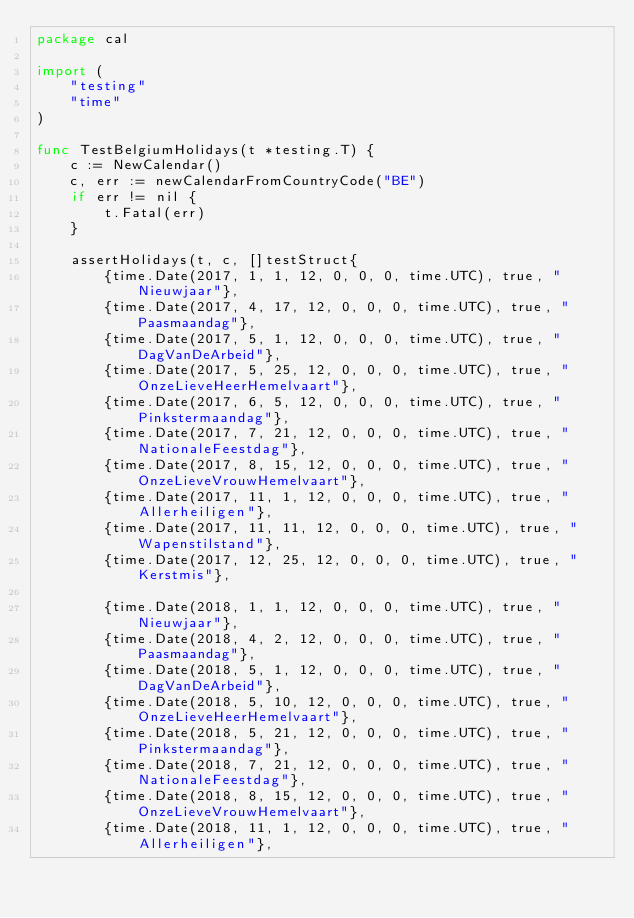Convert code to text. <code><loc_0><loc_0><loc_500><loc_500><_Go_>package cal

import (
	"testing"
	"time"
)

func TestBelgiumHolidays(t *testing.T) {
	c := NewCalendar()
	c, err := newCalendarFromCountryCode("BE")
	if err != nil {
		t.Fatal(err)
	}

	assertHolidays(t, c, []testStruct{
		{time.Date(2017, 1, 1, 12, 0, 0, 0, time.UTC), true, "Nieuwjaar"},
		{time.Date(2017, 4, 17, 12, 0, 0, 0, time.UTC), true, "Paasmaandag"},
		{time.Date(2017, 5, 1, 12, 0, 0, 0, time.UTC), true, "DagVanDeArbeid"},
		{time.Date(2017, 5, 25, 12, 0, 0, 0, time.UTC), true, "OnzeLieveHeerHemelvaart"},
		{time.Date(2017, 6, 5, 12, 0, 0, 0, time.UTC), true, "Pinkstermaandag"},
		{time.Date(2017, 7, 21, 12, 0, 0, 0, time.UTC), true, "NationaleFeestdag"},
		{time.Date(2017, 8, 15, 12, 0, 0, 0, time.UTC), true, "OnzeLieveVrouwHemelvaart"},
		{time.Date(2017, 11, 1, 12, 0, 0, 0, time.UTC), true, "Allerheiligen"},
		{time.Date(2017, 11, 11, 12, 0, 0, 0, time.UTC), true, "Wapenstilstand"},
		{time.Date(2017, 12, 25, 12, 0, 0, 0, time.UTC), true, "Kerstmis"},

		{time.Date(2018, 1, 1, 12, 0, 0, 0, time.UTC), true, "Nieuwjaar"},
		{time.Date(2018, 4, 2, 12, 0, 0, 0, time.UTC), true, "Paasmaandag"},
		{time.Date(2018, 5, 1, 12, 0, 0, 0, time.UTC), true, "DagVanDeArbeid"},
		{time.Date(2018, 5, 10, 12, 0, 0, 0, time.UTC), true, "OnzeLieveHeerHemelvaart"},
		{time.Date(2018, 5, 21, 12, 0, 0, 0, time.UTC), true, "Pinkstermaandag"},
		{time.Date(2018, 7, 21, 12, 0, 0, 0, time.UTC), true, "NationaleFeestdag"},
		{time.Date(2018, 8, 15, 12, 0, 0, 0, time.UTC), true, "OnzeLieveVrouwHemelvaart"},
		{time.Date(2018, 11, 1, 12, 0, 0, 0, time.UTC), true, "Allerheiligen"},</code> 